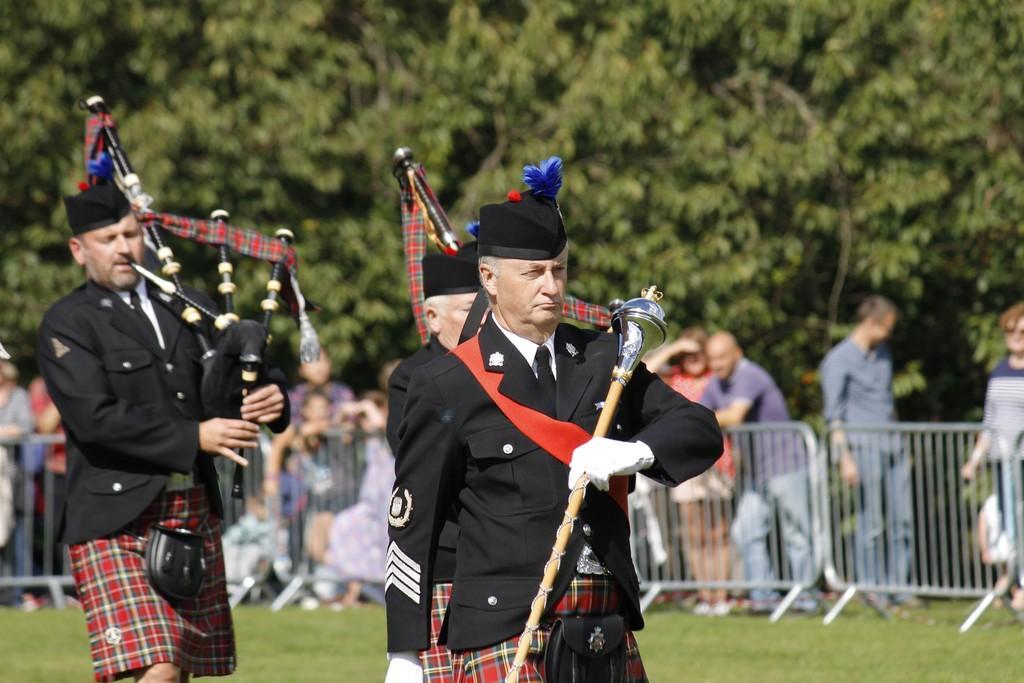Please provide a concise description of this image. In this picture, we can see a few people, and among them a few are in a dress code are holding musical instruments, we can see the ground with grass, fencing, and in the background we can see trees. 